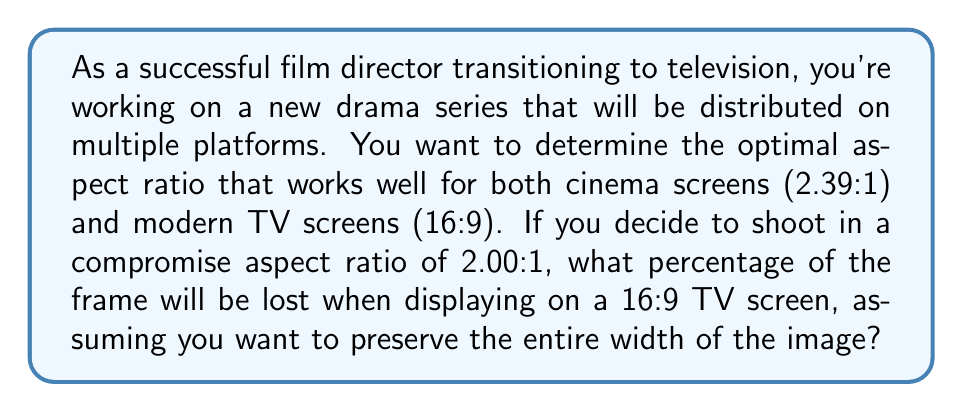Solve this math problem. Let's approach this step-by-step:

1) First, let's understand what the aspect ratios mean:
   - 2.00:1 means the width is 2 times the height
   - 16:9 means the width is 16/9 ≈ 1.78 times the height

2) Let's set the width of both frames to be 1 (unit doesn't matter). Now we can calculate the heights:
   - For 2.00:1 aspect ratio: height = 1/2 = 0.5
   - For 16:9 aspect ratio: height = 9/16 ≈ 0.5625

3) To preserve the entire width on a 16:9 screen, we need to crop the height of the 2.00:1 image.

4) The amount of height we need to crop is:
   $$ \text{Crop amount} = 0.5 - 0.5625 = -0.0625 $$
   The negative value indicates we need to add black bars instead of cropping.

5) To calculate the percentage of the frame lost, we divide the crop amount by the original height and multiply by 100:

   $$ \text{Percentage lost} = \frac{\text{Crop amount}}{\text{Original height}} \times 100\% $$
   $$ = \frac{-0.0625}{0.5} \times 100\% = -12.5\% $$

6) The negative percentage indicates that we're not losing any of the original frame, but rather adding 12.5% of black bars (letterboxing).

7) Therefore, the percentage of the original frame preserved is 100%, and the added black bars account for 12.5% of the 16:9 frame height.
Answer: 0% lost; 12.5% black bars added 